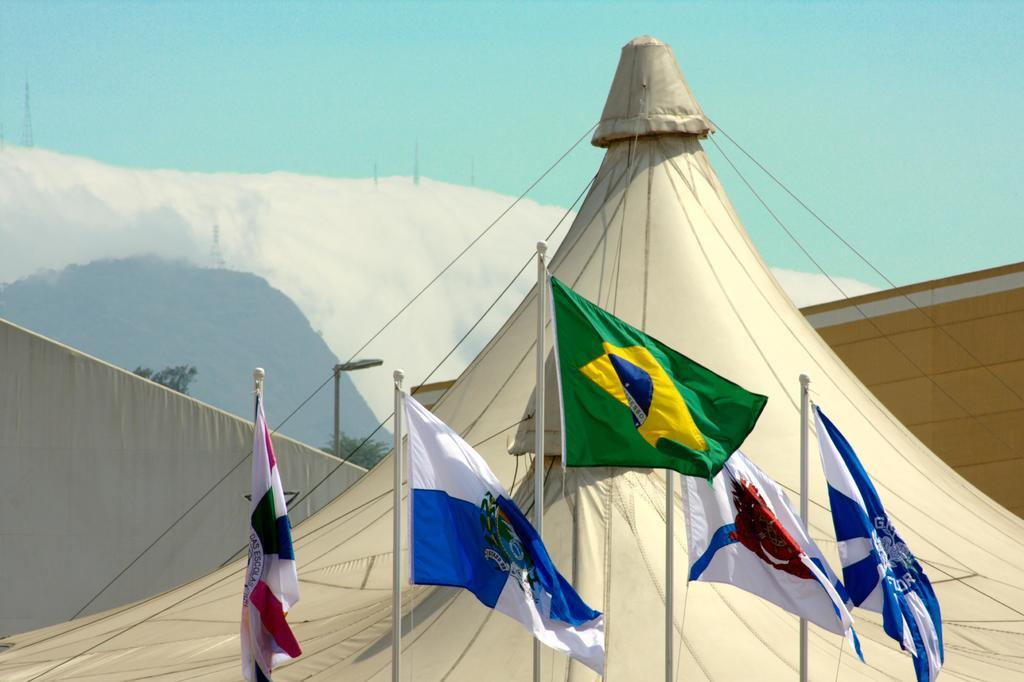What is the main subject of the image? The main subject of the image is a camp. What can be seen in addition to the camp? There are flags in the image. What is visible in the background of the image? The sky is visible in the background of the image. How many beams are supporting the camp in the image? There is no information about beams supporting the camp in the image. Can you see an airplane flying over the camp in the image? There is no airplane visible in the image. 